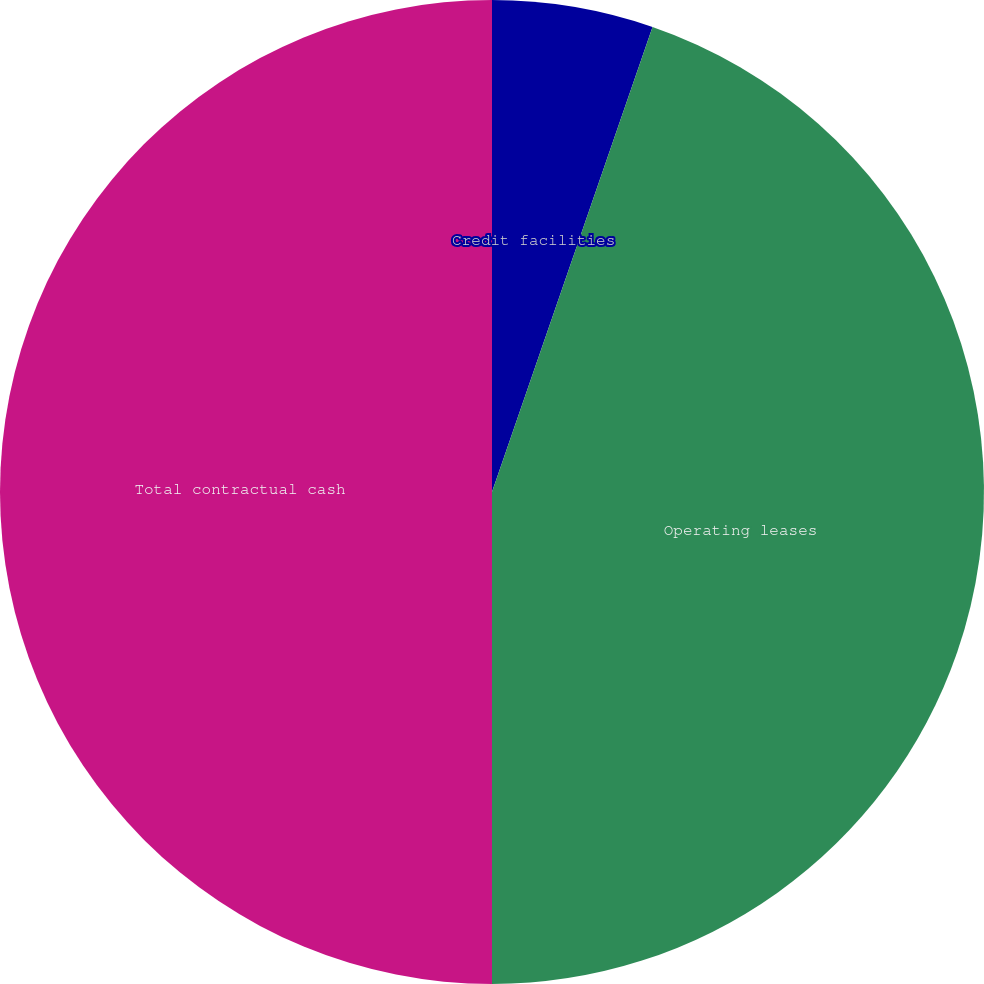<chart> <loc_0><loc_0><loc_500><loc_500><pie_chart><fcel>Credit facilities<fcel>Operating leases<fcel>Total contractual cash<nl><fcel>5.29%<fcel>44.71%<fcel>50.0%<nl></chart> 